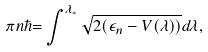Convert formula to latex. <formula><loc_0><loc_0><loc_500><loc_500>\pi n \hbar { = } \int ^ { \lambda _ { * } } \sqrt { 2 ( \epsilon _ { n } - V ( \lambda ) ) } d \lambda ,</formula> 